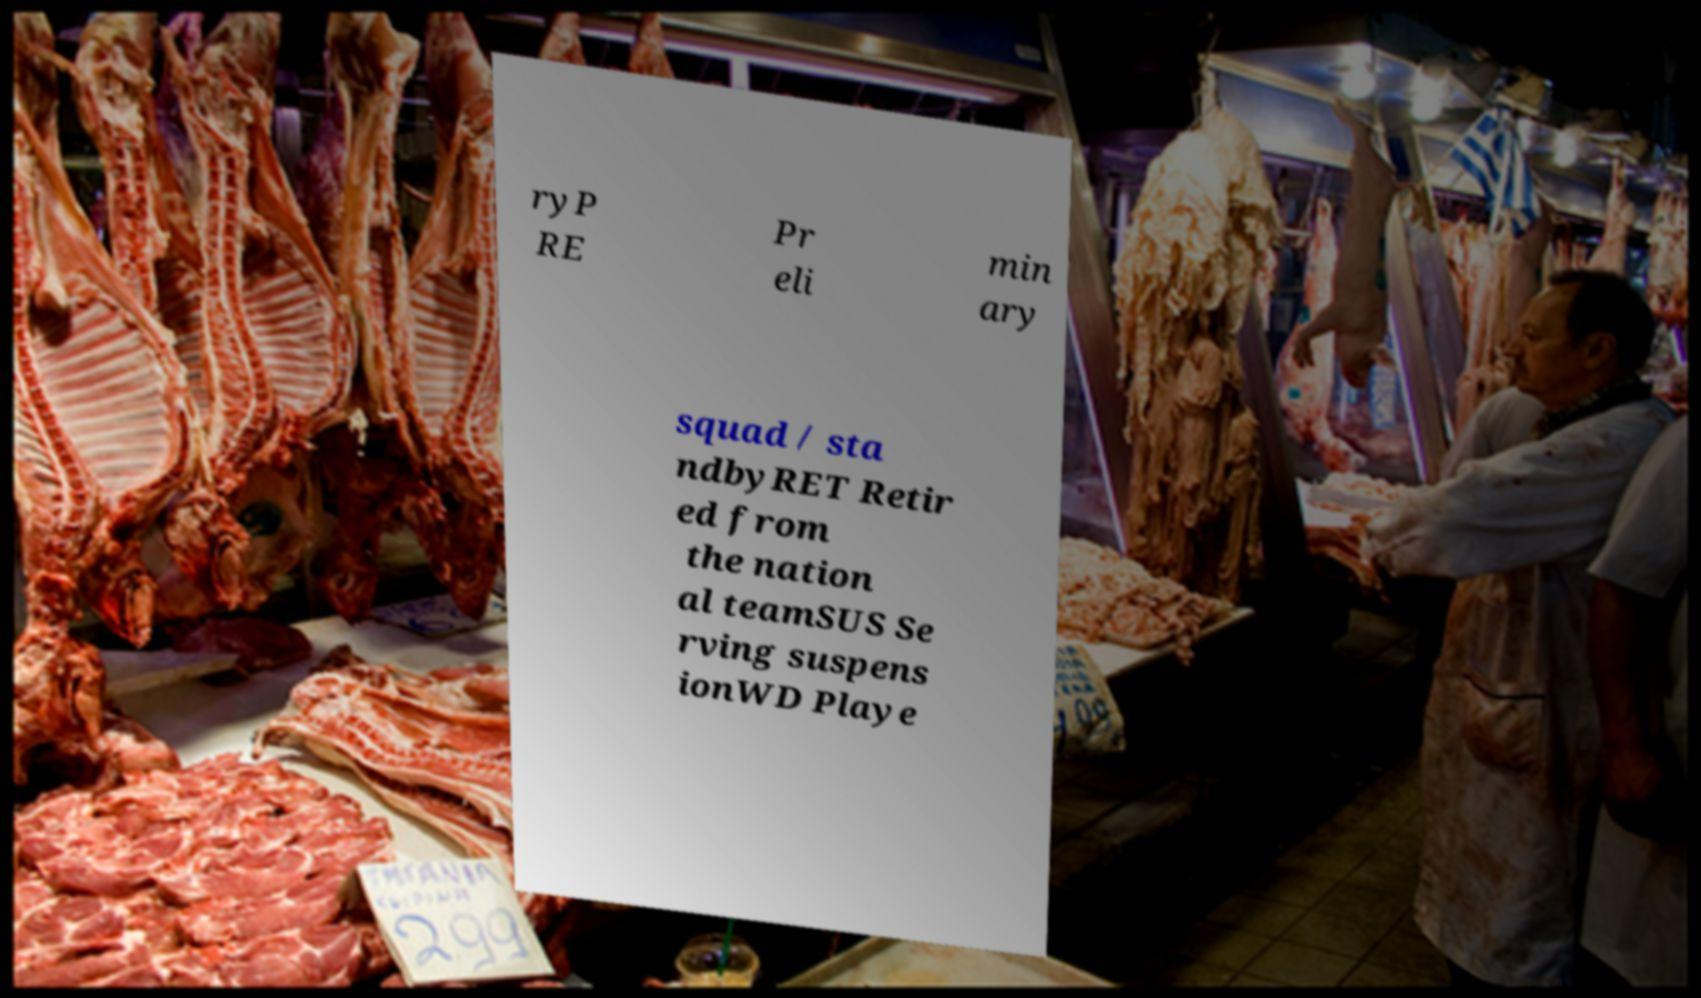For documentation purposes, I need the text within this image transcribed. Could you provide that? ryP RE Pr eli min ary squad / sta ndbyRET Retir ed from the nation al teamSUS Se rving suspens ionWD Playe 